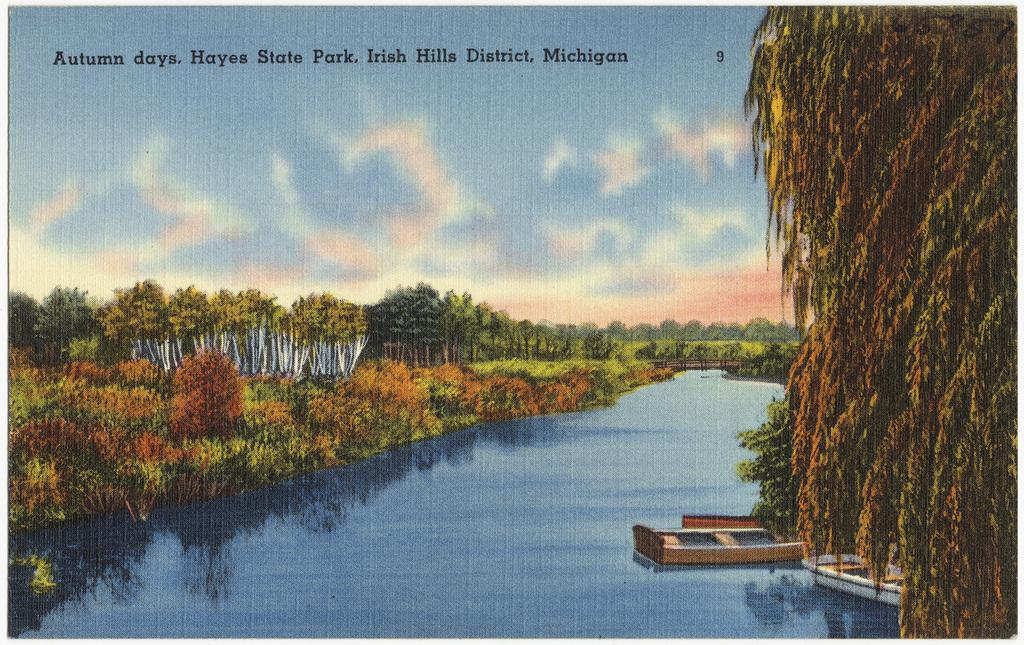What is the primary element in the image? There is water in the image. What is present on the water? There are boats on the water. What can be seen on either side of the water? There are trees on either side of the water. What is located in the left top corner of the image? There is text or an image in the left top corner of the image. What type of collar is visible on the shirt of the uncle in the image? There is no uncle, shirt, or collar present in the image. 